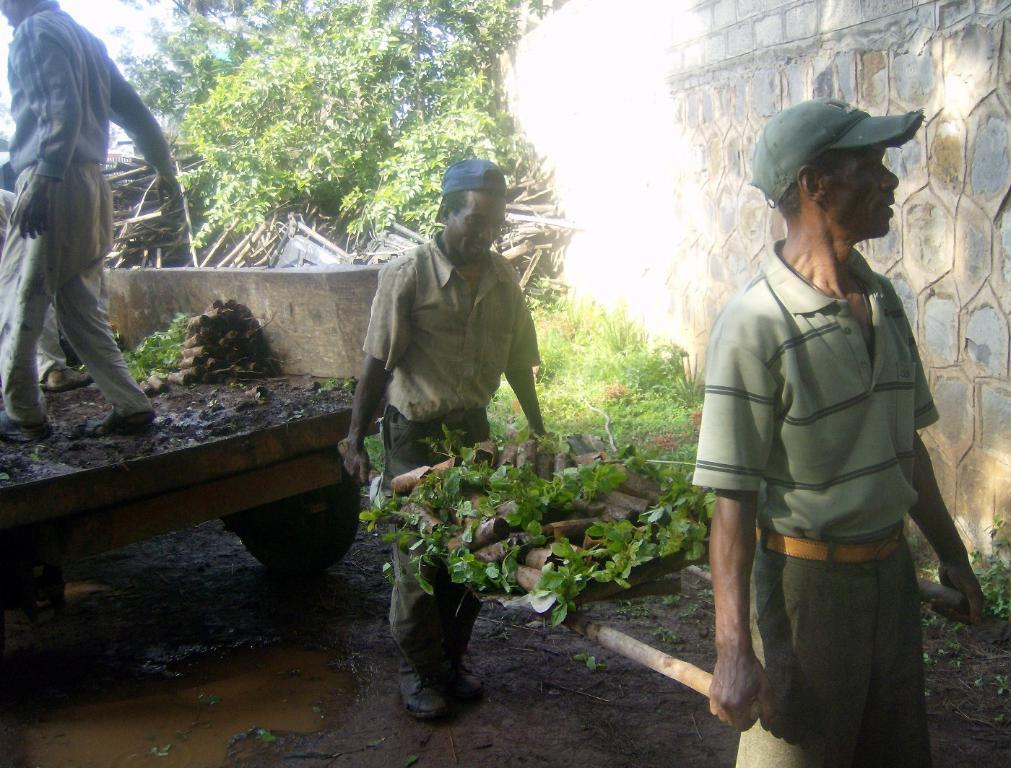What vehicle is located on the left side of the image? There is a truck on the left side of the image. What type of structure can be seen on the right side of the image? There is a stone wall on the right side of the image. What type of vegetation is present in the image? There are trees in the image. What part of the natural environment is visible in the image? The sky is visible in the image. Who or what else can be seen in the image? There are people in the image. What type of education is being offered to the trees in the image? There is no indication in the image that the trees are receiving any education. What point is being made by the stone wall in the image? The stone wall is a structural element in the image and does not make a point or convey a message. 